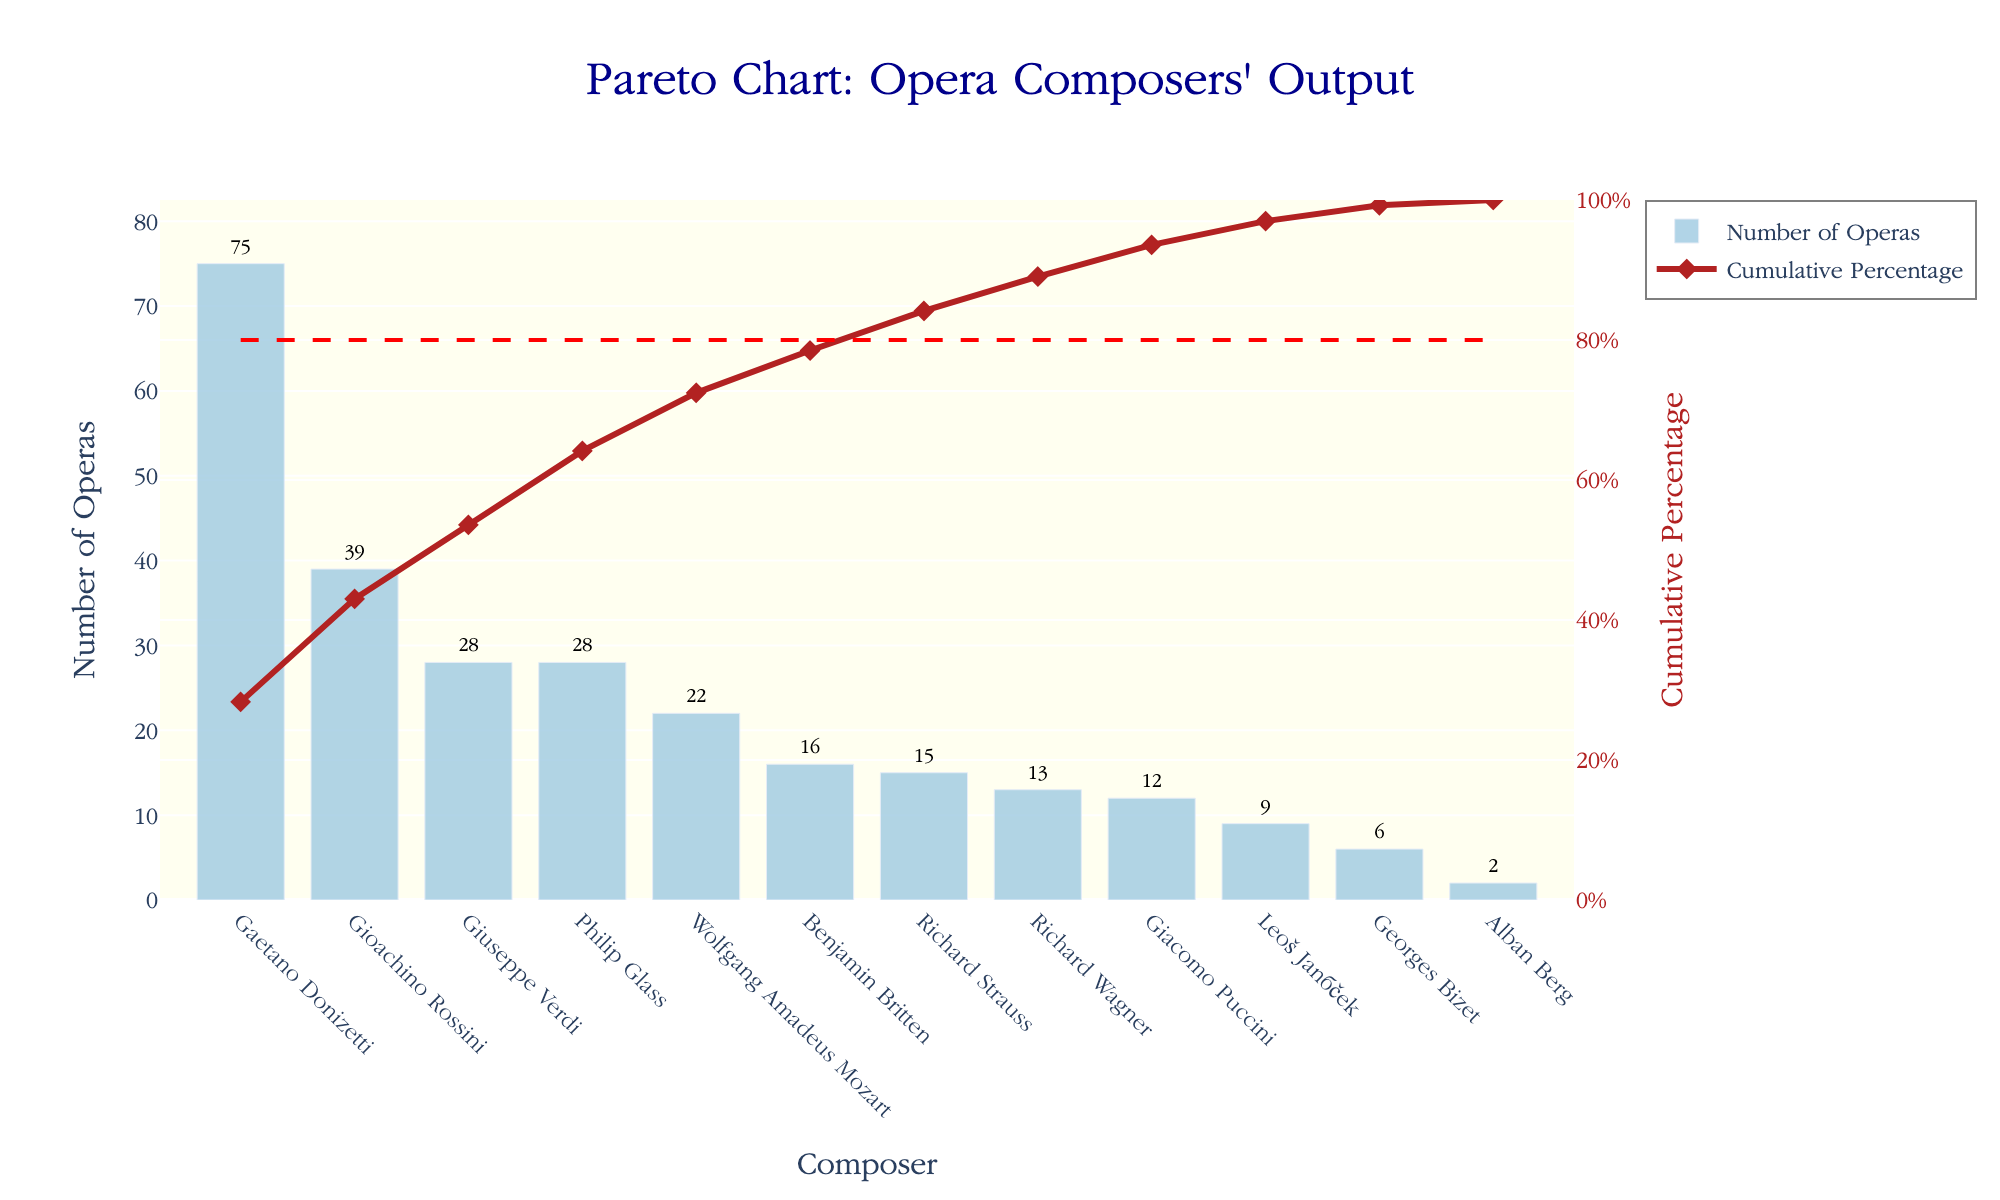Which opera composer has the highest number of operas? Gioachino Rossini has the highest bar in the bar chart, indicating that he has the highest number of operas.
Answer: Gioachino Rossini What is the cumulative percentage of operas after adding Giuseppe Verdi's output? Locate Giuseppe Verdi's bar, note his position in the order, and look at the corresponding point on the cumulative percentage line just after adding his works.
Answer: 39.96% How many composers have written fewer than 10 operas? Look at the bars that represent fewer than 10 operas. These composeres are Georges Bizet, Leoš Janáček, and Alban Berg.
Answer: 3 Compare the number of operas written by Wolfgang Amadeus Mozart and Richard Strauss. Which composer has written more? Observe the heights of the bars for Wolfgang Amadeus Mozart (22) and Richard Strauss (15). Mozart has a taller bar.
Answer: Wolfgang Amadeus Mozart What's the difference in the number of operas between Leonardo Donizetti and Giuseppe Verdi? Subtract the number of operas of Giuseppe Verdi from Gaetano Donizetti's. Donizetti's bar shows 75, while Verdi's bar shows 28, so 75 - 28.
Answer: 47 Which composers together account for approximately 80% of all operas composed? Examine the cumulative percentage line and find where it crosses 80%. The composers up to and including the point where the line hits 80% include Gaetano Donizetti, Gioachino Rossini, Giuseppe Verdi, Wolfgang Amadeus Mozart, and Philip Glass.
Answer: Donizetti, Rossini, Verdi, Mozart, Glass What percentage of operas are composed by the top 3 composers? Sum the number of operas of the top 3 composers (75 + 39 + 28) and divide by total operas, then multiply by 100 to get the percentage.
Answer: 71.08% How many operas in total did Leoš Janáček and Georges Bizet compose? Add the number of operas of Leoš Janáček (9) and Georges Bizet (6). Hence, 9 + 6.
Answer: 15 What is the cumulative percentage after including Gioachino Rossini? Look at the cumulative percentage line immediately after the contribution of Gioachino Rossini, who is the second most prolific.
Answer: 51.38% 